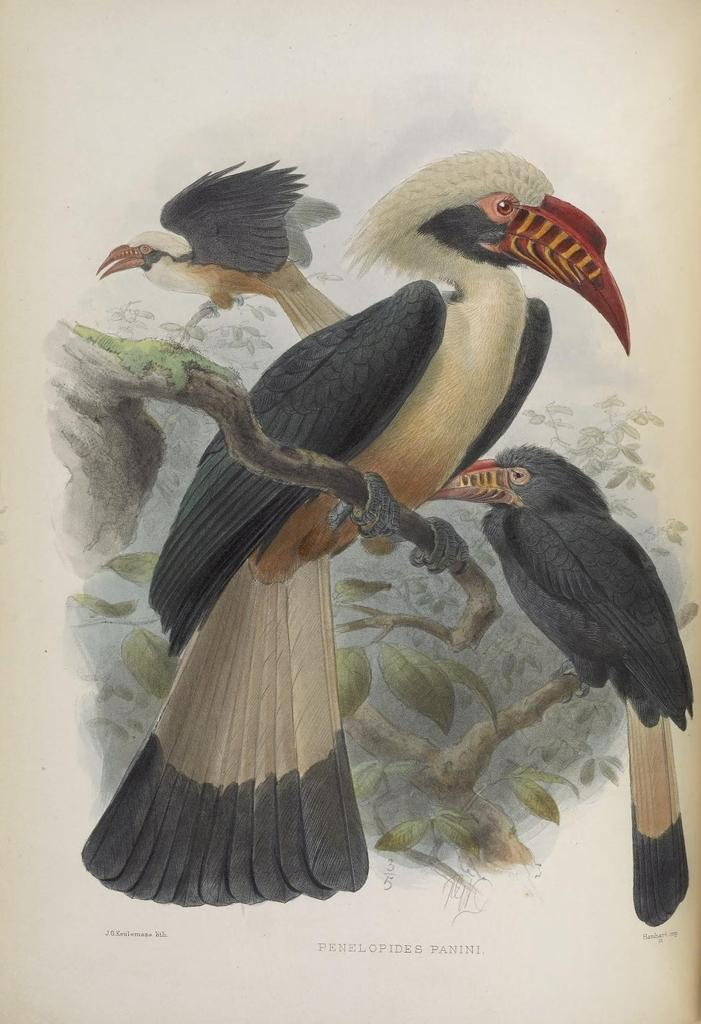What is depicted on the white surface in the image? There is a painting on a white surface in the image. What type of animals can be seen in the painting? There are birds on tree stems in the painting. What else can be seen in the painting besides the birds? Leaves are present in the painting. What else is visible in the image besides the painting? There is some text visible in the image. What type of yam is being used to create the painting in the image? There is no yam present in the image, and yams are not used for creating paintings. 